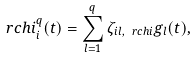<formula> <loc_0><loc_0><loc_500><loc_500>\ r c h i _ { i } ^ { q } ( t ) = \sum _ { l = 1 } ^ { q } \zeta _ { i l , \ r c h i } g _ { l } ( t ) ,</formula> 